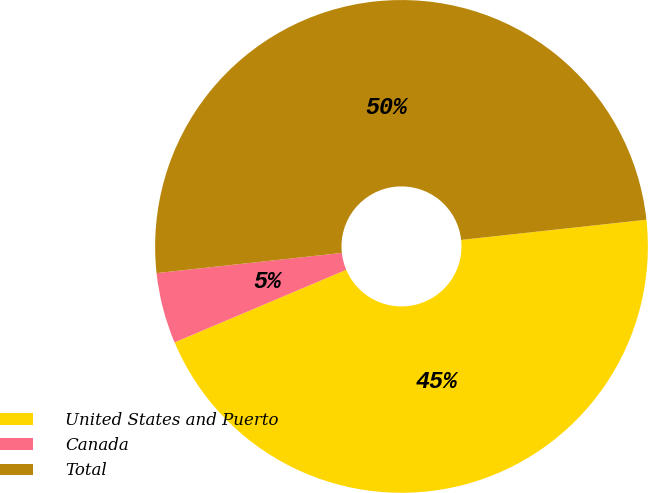Convert chart. <chart><loc_0><loc_0><loc_500><loc_500><pie_chart><fcel>United States and Puerto<fcel>Canada<fcel>Total<nl><fcel>45.36%<fcel>4.64%<fcel>50.0%<nl></chart> 